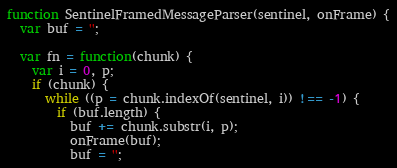<code> <loc_0><loc_0><loc_500><loc_500><_JavaScript_>function SentinelFramedMessageParser(sentinel, onFrame) {
  var buf = '';

  var fn = function(chunk) {
    var i = 0, p;
    if (chunk) {
      while ((p = chunk.indexOf(sentinel, i)) !== -1) {
        if (buf.length) {
          buf += chunk.substr(i, p);
          onFrame(buf);
          buf = '';</code> 